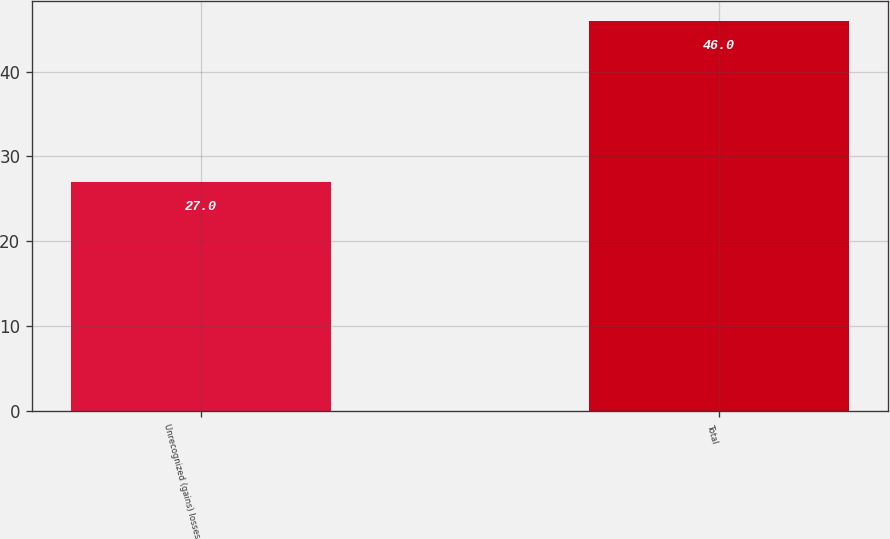Convert chart to OTSL. <chart><loc_0><loc_0><loc_500><loc_500><bar_chart><fcel>Unrecognized (gains) losses<fcel>Total<nl><fcel>27<fcel>46<nl></chart> 